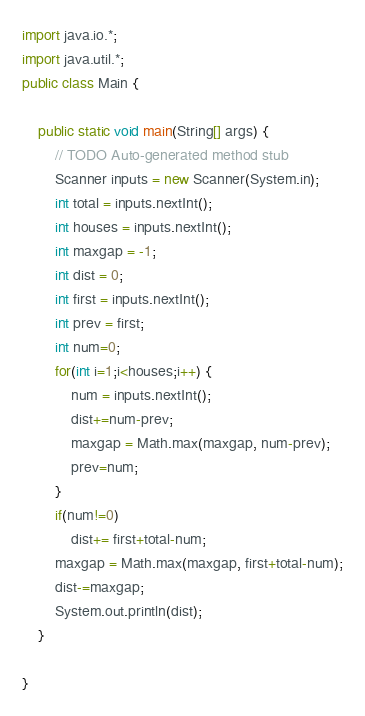Convert code to text. <code><loc_0><loc_0><loc_500><loc_500><_Java_>import java.io.*;
import java.util.*;
public class Main {

	public static void main(String[] args) {
		// TODO Auto-generated method stub
		Scanner inputs = new Scanner(System.in);
		int total = inputs.nextInt();
		int houses = inputs.nextInt();
		int maxgap = -1;
		int dist = 0;
		int first = inputs.nextInt();
		int prev = first;
		int num=0;
		for(int i=1;i<houses;i++) {
			num = inputs.nextInt();
			dist+=num-prev;
			maxgap = Math.max(maxgap, num-prev);
			prev=num;
		}
		if(num!=0)
			dist+= first+total-num;
		maxgap = Math.max(maxgap, first+total-num);
		dist-=maxgap;
		System.out.println(dist);
	}

}
</code> 